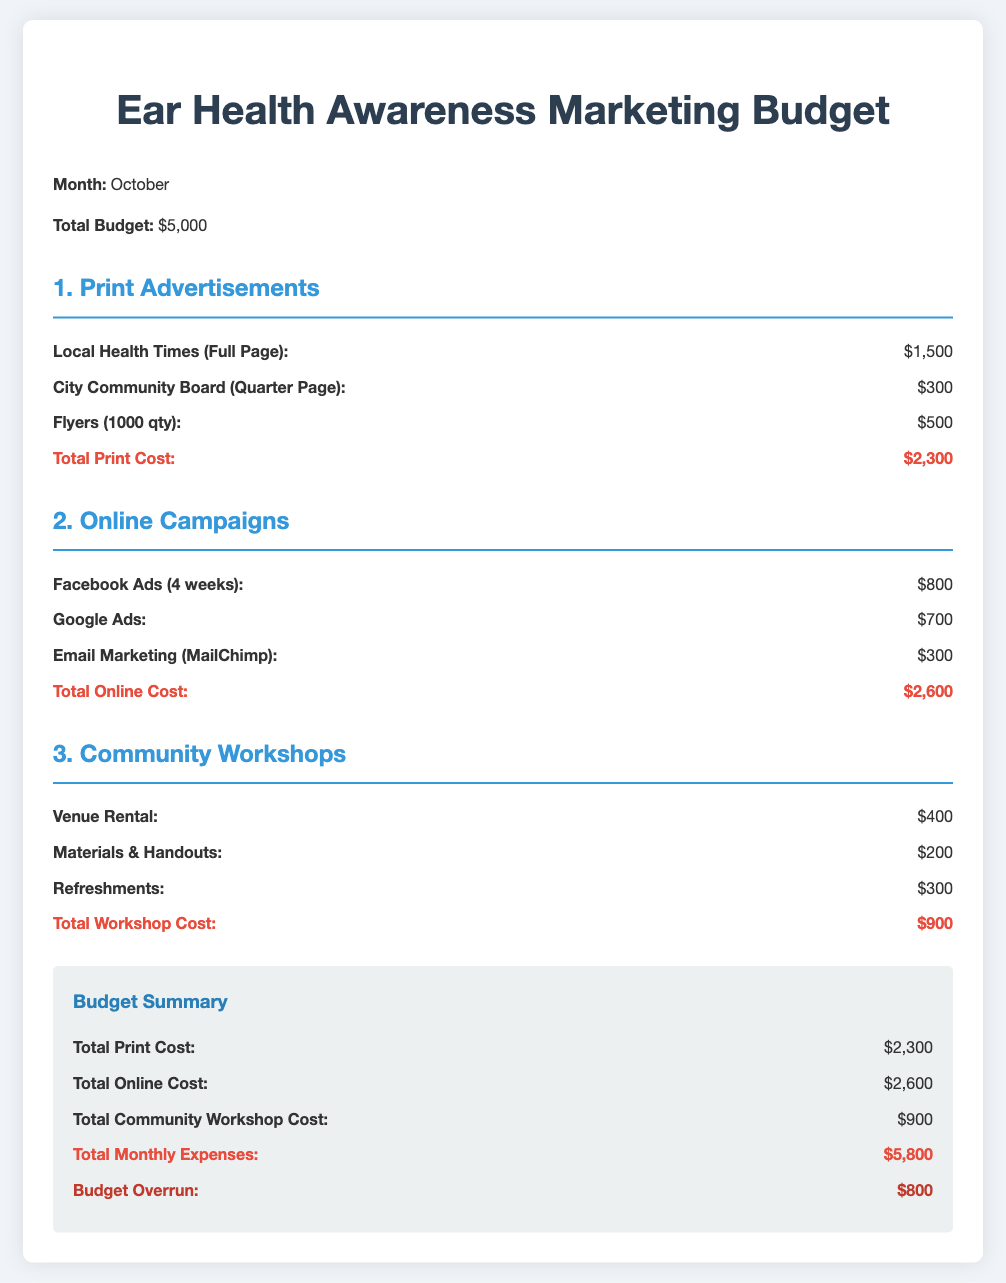What is the total budget? The total budget for the month is stated clearly in the document, which is $5,000.
Answer: $5,000 What is the cost for local print advertisements? The document lists the costs for local print advertisements including a full-page ad and a quarter-page ad. The total is $1,500 + $300 = $1,800.
Answer: $1,800 How much is allocated for Google Ads? The allocation for Google Ads is directly mentioned in the online campaigns section of the budget.
Answer: $700 What is the total cost for community workshops? The total cost for community workshops can be found in the community workshops section, which adds up the costs for venue rental, materials, and refreshments.
Answer: $900 What is the budget overrun amount? The budget overrun is calculated by comparing the total monthly expenses to the total budget, which indicates a discrepancy of $800.
Answer: $800 What is the cost of flyers? The cost of flyers is specified in the print advertisements section of the document.
Answer: $500 What is the total cost for online campaigns? The total for online campaigns is provided by summing the costs for Facebook ads, Google ads, and email marketing.
Answer: $2,600 What is the cost for venue rental? The venue rental cost is mentioned specifically under the community workshops section of the budget.
Answer: $400 What is included in the materials & handouts cost? The document does not specify what's included in this cost; it only lists the total for this line item.
Answer: $200 